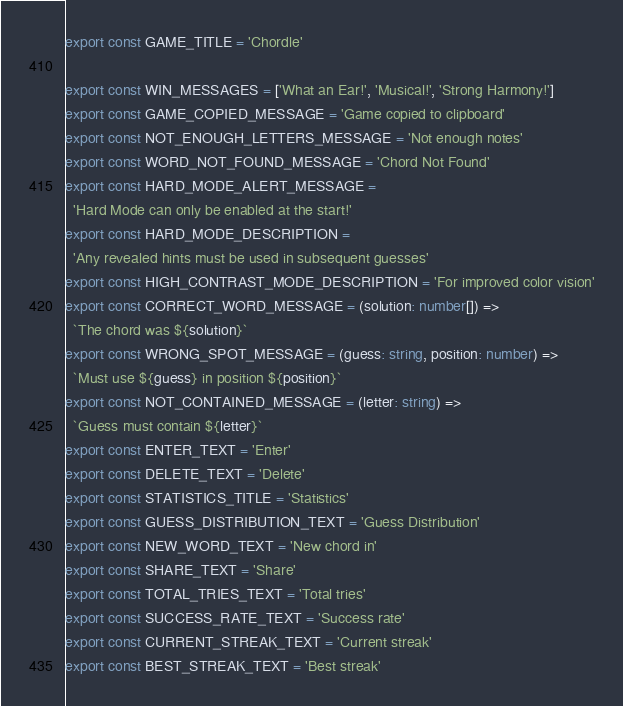Convert code to text. <code><loc_0><loc_0><loc_500><loc_500><_TypeScript_>export const GAME_TITLE = 'Chordle'

export const WIN_MESSAGES = ['What an Ear!', 'Musical!', 'Strong Harmony!']
export const GAME_COPIED_MESSAGE = 'Game copied to clipboard'
export const NOT_ENOUGH_LETTERS_MESSAGE = 'Not enough notes'
export const WORD_NOT_FOUND_MESSAGE = 'Chord Not Found'
export const HARD_MODE_ALERT_MESSAGE =
  'Hard Mode can only be enabled at the start!'
export const HARD_MODE_DESCRIPTION =
  'Any revealed hints must be used in subsequent guesses'
export const HIGH_CONTRAST_MODE_DESCRIPTION = 'For improved color vision'
export const CORRECT_WORD_MESSAGE = (solution: number[]) =>
  `The chord was ${solution}`
export const WRONG_SPOT_MESSAGE = (guess: string, position: number) =>
  `Must use ${guess} in position ${position}`
export const NOT_CONTAINED_MESSAGE = (letter: string) =>
  `Guess must contain ${letter}`
export const ENTER_TEXT = 'Enter'
export const DELETE_TEXT = 'Delete'
export const STATISTICS_TITLE = 'Statistics'
export const GUESS_DISTRIBUTION_TEXT = 'Guess Distribution'
export const NEW_WORD_TEXT = 'New chord in'
export const SHARE_TEXT = 'Share'
export const TOTAL_TRIES_TEXT = 'Total tries'
export const SUCCESS_RATE_TEXT = 'Success rate'
export const CURRENT_STREAK_TEXT = 'Current streak'
export const BEST_STREAK_TEXT = 'Best streak'
</code> 